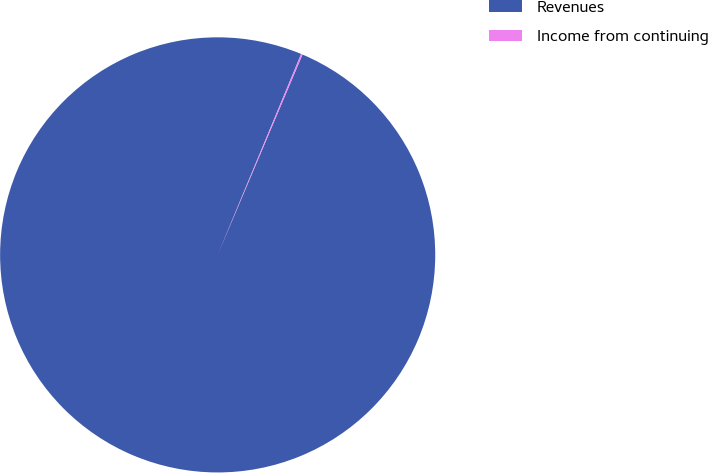<chart> <loc_0><loc_0><loc_500><loc_500><pie_chart><fcel>Revenues<fcel>Income from continuing<nl><fcel>99.89%<fcel>0.11%<nl></chart> 